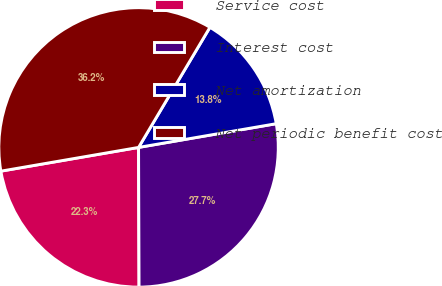<chart> <loc_0><loc_0><loc_500><loc_500><pie_chart><fcel>Service cost<fcel>Interest cost<fcel>Net amortization<fcel>Net periodic benefit cost<nl><fcel>22.34%<fcel>27.66%<fcel>13.75%<fcel>36.25%<nl></chart> 